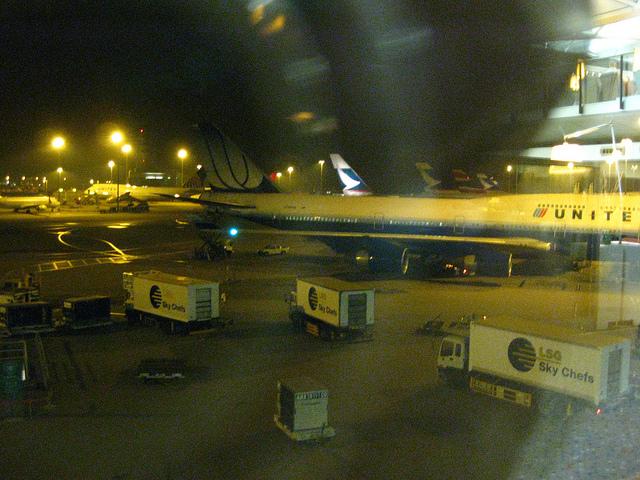How many airplanes are there?
Give a very brief answer. 3. What is the name of the airline on the plane?
Quick response, please. United. What types of vehicles are seen?
Write a very short answer. Trucks. Is this  a airport with a lot of planes?
Be succinct. Yes. 